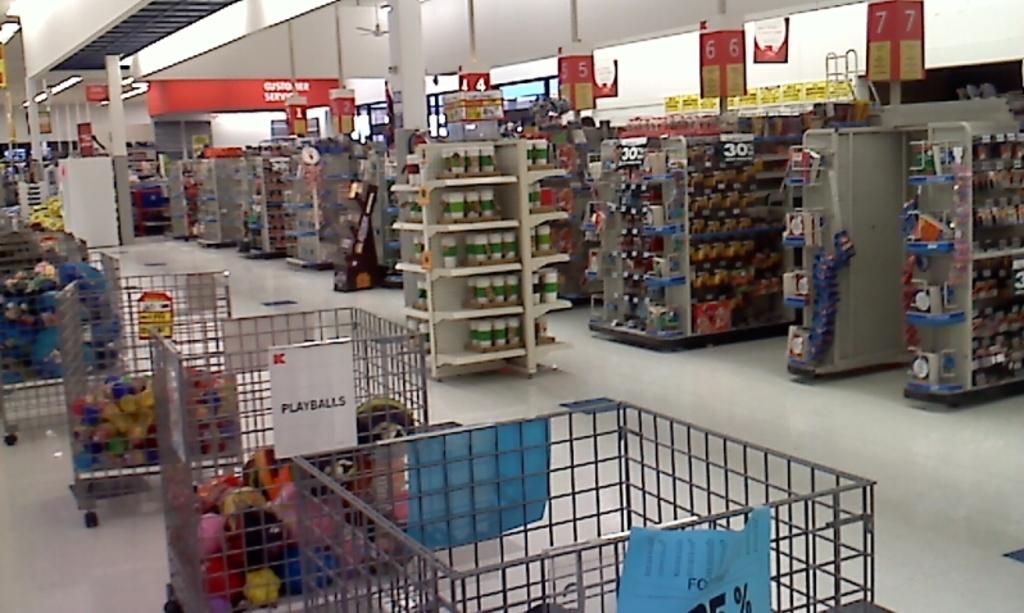<image>
Offer a succinct explanation of the picture presented. Rows of bins at a K-Mart store with one bin full of playballs. 